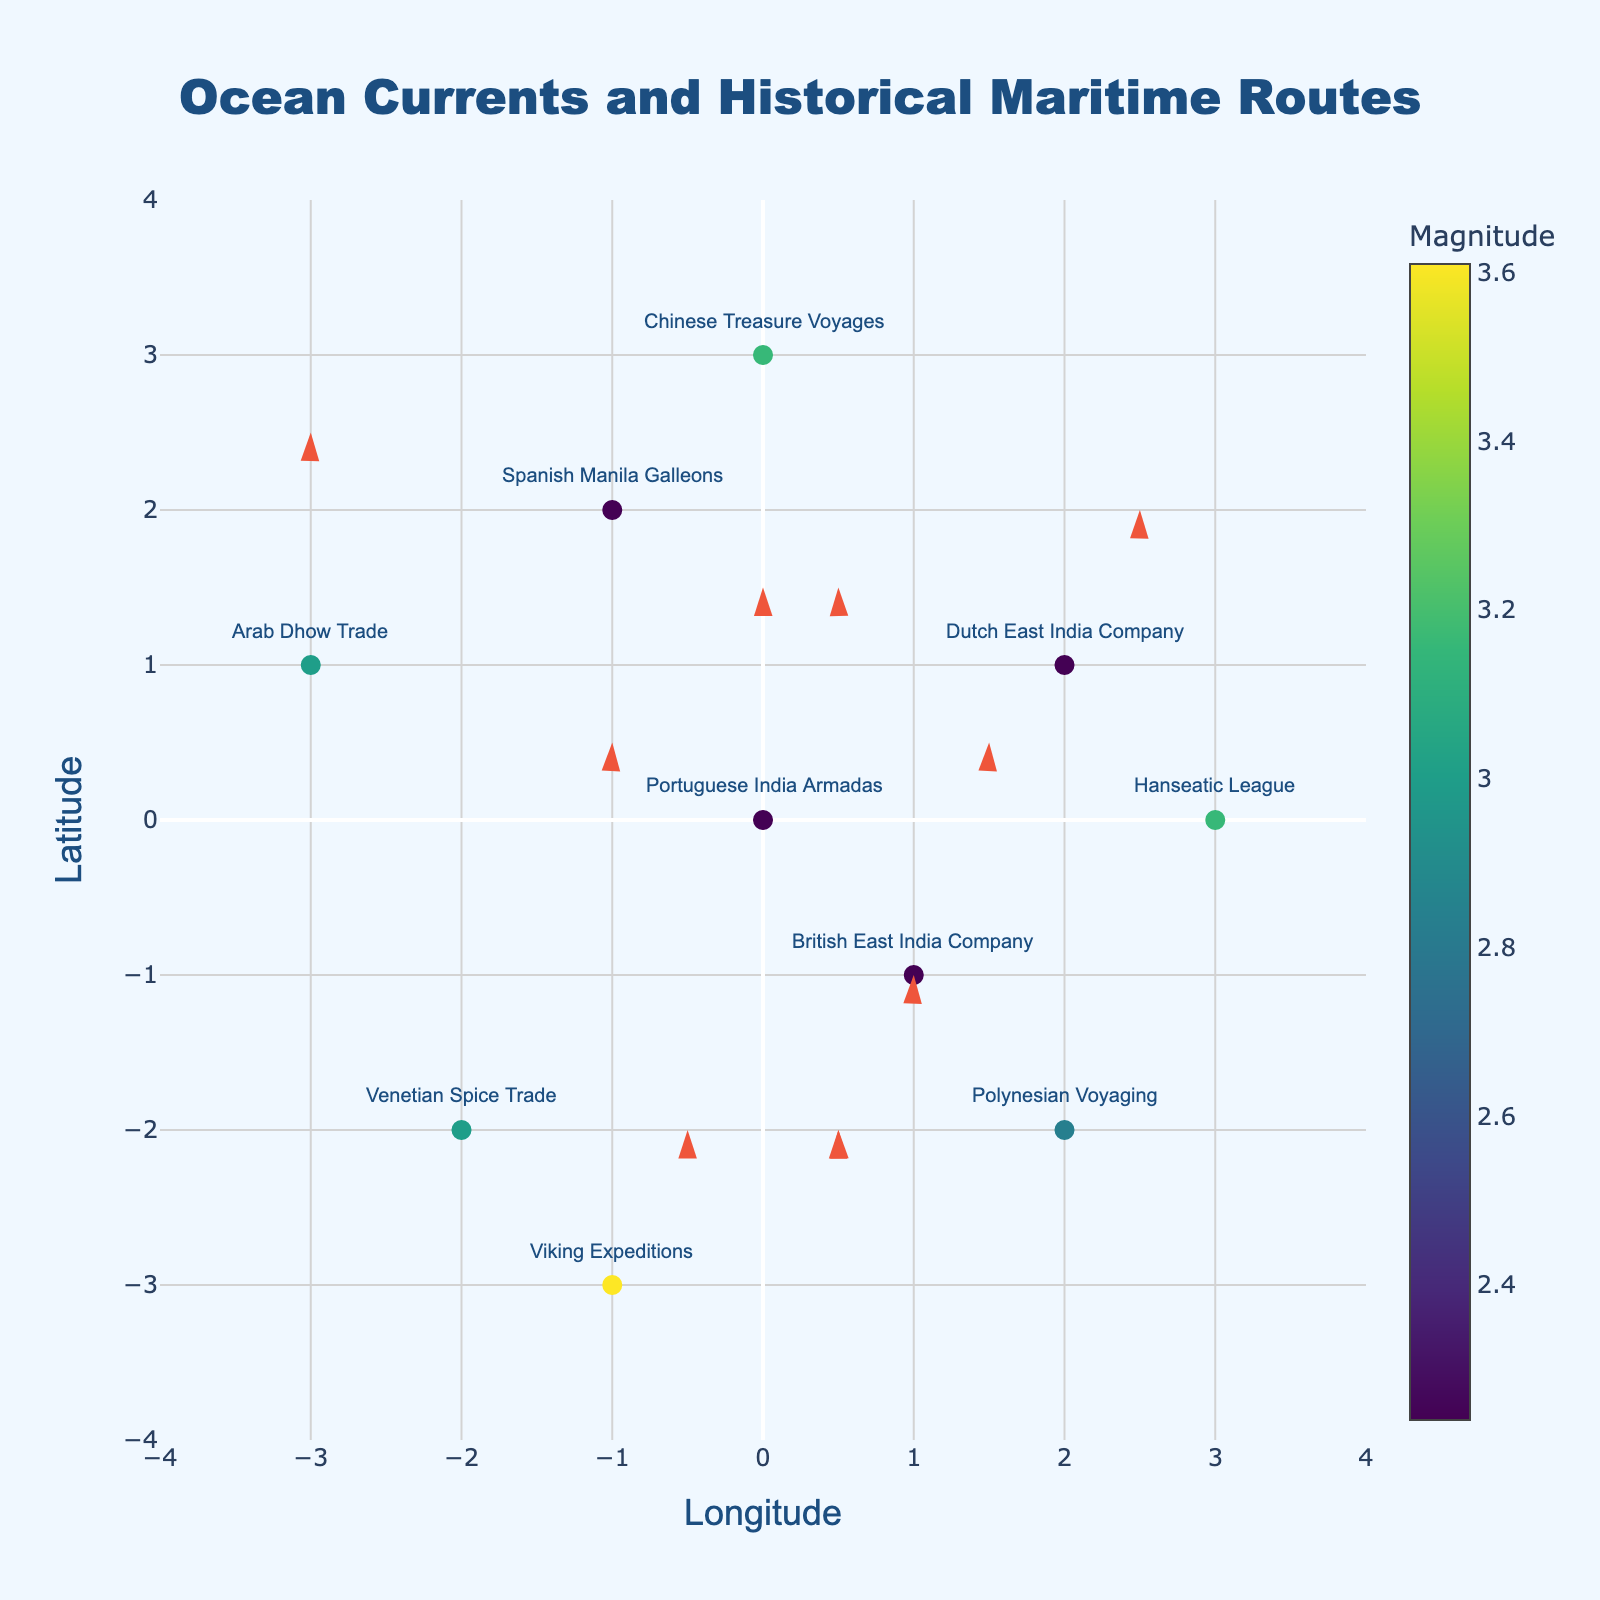How many maritime routes are represented in the plot? By counting the labels associated with each data point, we find that there are 10 distinctive maritime routes mentioned in the plot.
Answer: 10 What is the title of the plot? The plot title is located at the top center and reads "Ocean Currents and Historical Maritime Routes."
Answer: Ocean Currents and Historical Maritime Routes Which route has the strongest ocean current magnitude? By looking at the color bar representing the magnitudes, the Viking Expeditions route has the highest magnitude value of 3.61.
Answer: Viking Expeditions Which maritime route is at the coordinates (2, -2)? By locating the coordinates (2, -2) on the plot, we find that the Polynesian Voyaging route is represented at these coordinates.
Answer: Polynesian Voyaging What is the general direction of the ocean current for the Chinese Treasure Voyages? The Chinese Treasure Voyages are at coordinates (0, 3) with an ocean current direction vector (1, -3). This vector points southeast.
Answer: Southeast Which routes have the same ocean current magnitude? The Portuguese India Armadas, Dutch East India Company, and Spanish Manila Galleons all have a magnitude of 2.24.
Answer: Portuguese India Armadas, Dutch East India Company, Spanish Manila Galleons Compare the magnitudes of the British East India Company and the Hanseatic League routes. Which has a greater magnitude? The magnitude of the British East India Company is 2.24, and for the Hanseatic League, it is 3.16. Hence, the Hanseatic League has a greater magnitude.
Answer: Hanseatic League What are the longitude and latitude ranges in the plot? The longitude (x-axis) and latitude (y-axis) ranges are from -4 to 4 as shown by the axes labels.
Answer: -4 to 4 Which maritime route's ocean current direction is directly vertical? The Venetian Spice Trade has a direction vector (3, 0), which is completely horizontal. The Arab Dhow Trade's vector is (0, 3), which is the only one that is completely vertical.
Answer: Arab Dhow Trade What is the average magnitude of all the maritime routes? Sum of all magnitudes: 2.24 + 2.24 + 2.24 + 2.24 + 3.00 + 3.16 + 3.00 + 3.16 + 2.83 + 3.61 = 27.72. There are 10 routes, so the average magnitude is 27.72 / 10 = 2.772.
Answer: 2.772 